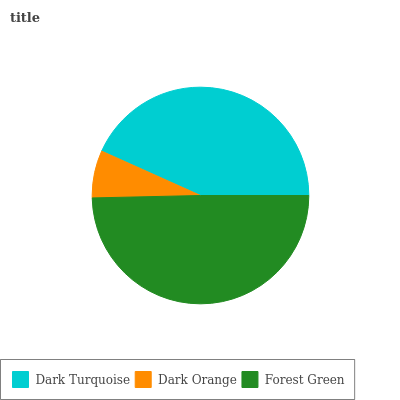Is Dark Orange the minimum?
Answer yes or no. Yes. Is Forest Green the maximum?
Answer yes or no. Yes. Is Forest Green the minimum?
Answer yes or no. No. Is Dark Orange the maximum?
Answer yes or no. No. Is Forest Green greater than Dark Orange?
Answer yes or no. Yes. Is Dark Orange less than Forest Green?
Answer yes or no. Yes. Is Dark Orange greater than Forest Green?
Answer yes or no. No. Is Forest Green less than Dark Orange?
Answer yes or no. No. Is Dark Turquoise the high median?
Answer yes or no. Yes. Is Dark Turquoise the low median?
Answer yes or no. Yes. Is Dark Orange the high median?
Answer yes or no. No. Is Forest Green the low median?
Answer yes or no. No. 